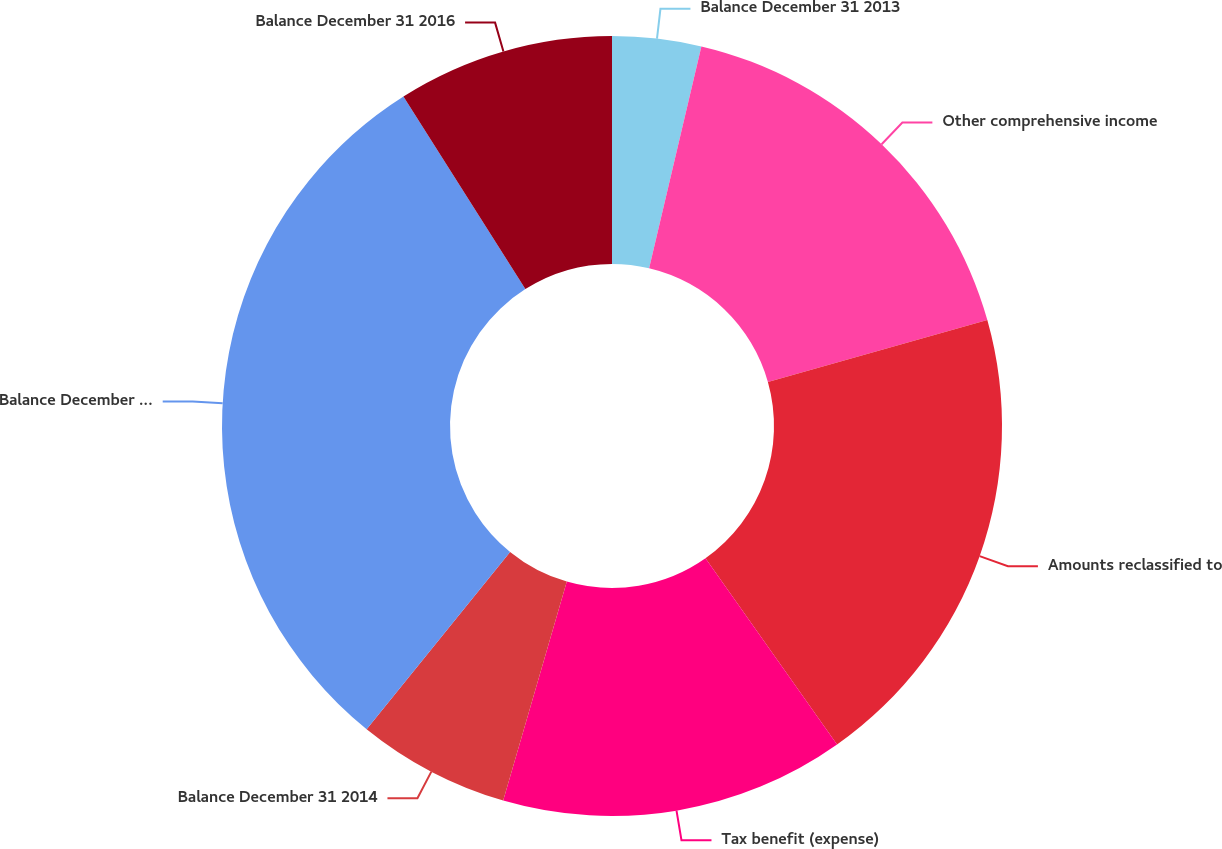<chart> <loc_0><loc_0><loc_500><loc_500><pie_chart><fcel>Balance December 31 2013<fcel>Other comprehensive income<fcel>Amounts reclassified to<fcel>Tax benefit (expense)<fcel>Balance December 31 2014<fcel>Balance December 31 2015<fcel>Balance December 31 2016<nl><fcel>3.68%<fcel>16.94%<fcel>19.59%<fcel>14.29%<fcel>6.33%<fcel>30.19%<fcel>8.98%<nl></chart> 